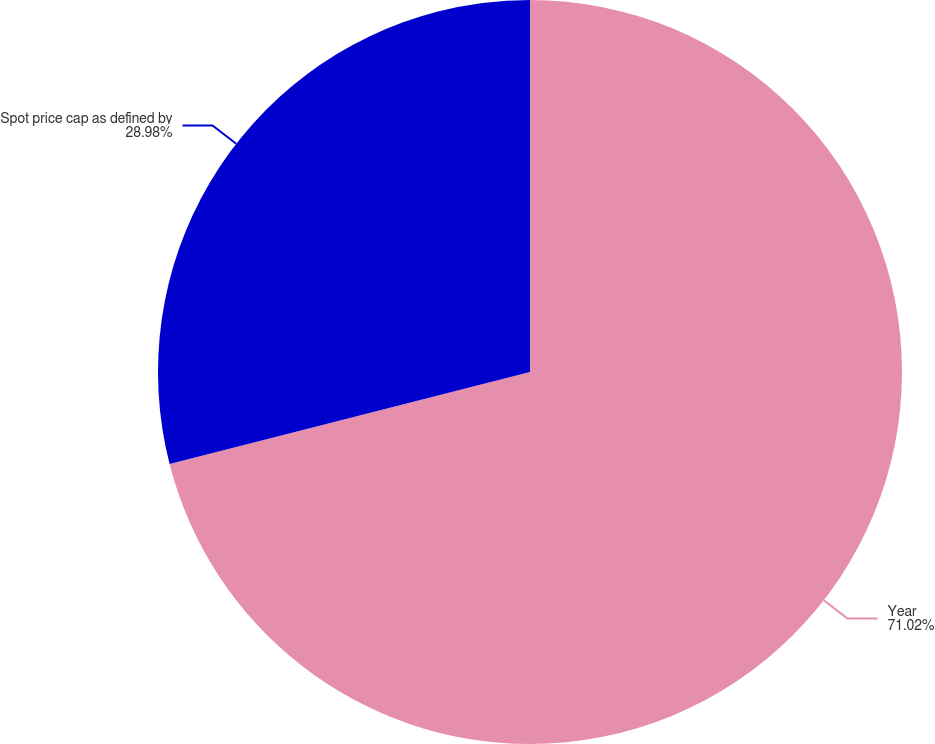Convert chart. <chart><loc_0><loc_0><loc_500><loc_500><pie_chart><fcel>Year<fcel>Spot price cap as defined by<nl><fcel>71.02%<fcel>28.98%<nl></chart> 